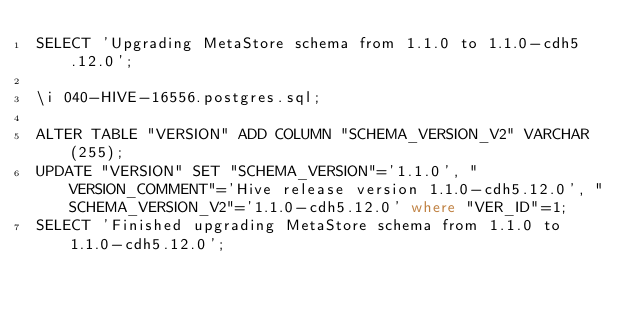Convert code to text. <code><loc_0><loc_0><loc_500><loc_500><_SQL_>SELECT 'Upgrading MetaStore schema from 1.1.0 to 1.1.0-cdh5.12.0';

\i 040-HIVE-16556.postgres.sql;

ALTER TABLE "VERSION" ADD COLUMN "SCHEMA_VERSION_V2" VARCHAR(255); 
UPDATE "VERSION" SET "SCHEMA_VERSION"='1.1.0', "VERSION_COMMENT"='Hive release version 1.1.0-cdh5.12.0', "SCHEMA_VERSION_V2"='1.1.0-cdh5.12.0' where "VER_ID"=1;
SELECT 'Finished upgrading MetaStore schema from 1.1.0 to 1.1.0-cdh5.12.0';
</code> 